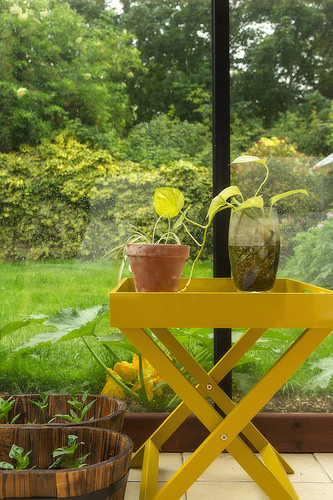<image>
Is the flower pot on the table tray? Yes. Looking at the image, I can see the flower pot is positioned on top of the table tray, with the table tray providing support. 